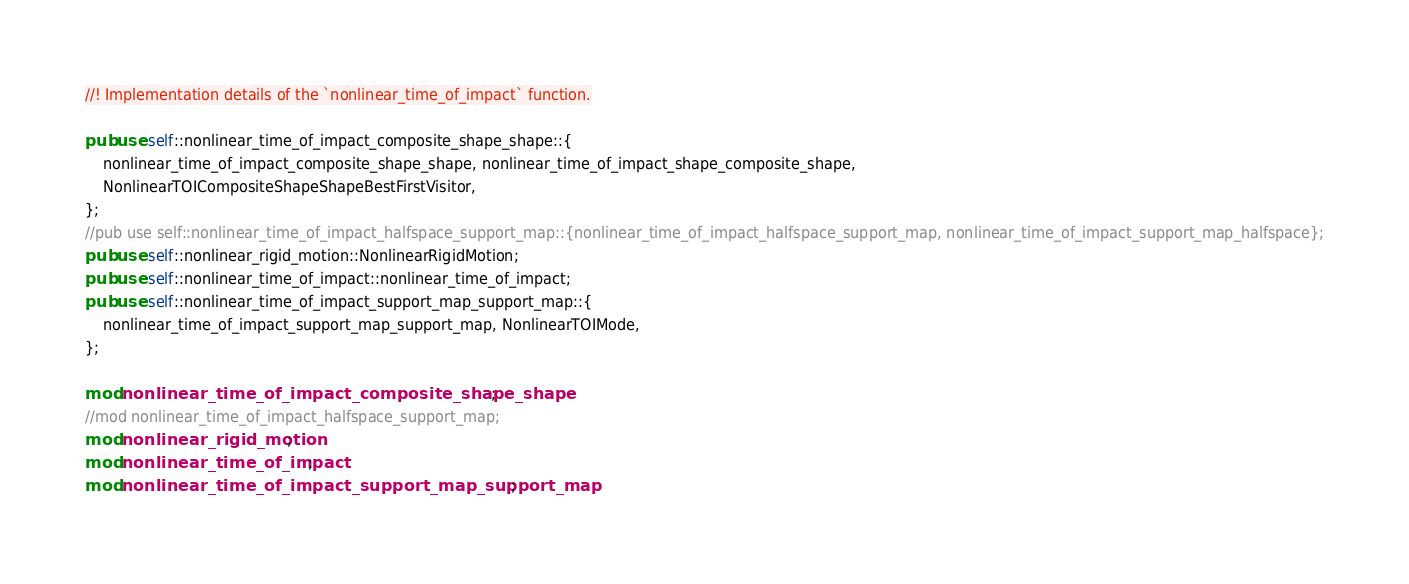Convert code to text. <code><loc_0><loc_0><loc_500><loc_500><_Rust_>//! Implementation details of the `nonlinear_time_of_impact` function.

pub use self::nonlinear_time_of_impact_composite_shape_shape::{
    nonlinear_time_of_impact_composite_shape_shape, nonlinear_time_of_impact_shape_composite_shape,
    NonlinearTOICompositeShapeShapeBestFirstVisitor,
};
//pub use self::nonlinear_time_of_impact_halfspace_support_map::{nonlinear_time_of_impact_halfspace_support_map, nonlinear_time_of_impact_support_map_halfspace};
pub use self::nonlinear_rigid_motion::NonlinearRigidMotion;
pub use self::nonlinear_time_of_impact::nonlinear_time_of_impact;
pub use self::nonlinear_time_of_impact_support_map_support_map::{
    nonlinear_time_of_impact_support_map_support_map, NonlinearTOIMode,
};

mod nonlinear_time_of_impact_composite_shape_shape;
//mod nonlinear_time_of_impact_halfspace_support_map;
mod nonlinear_rigid_motion;
mod nonlinear_time_of_impact;
mod nonlinear_time_of_impact_support_map_support_map;
</code> 